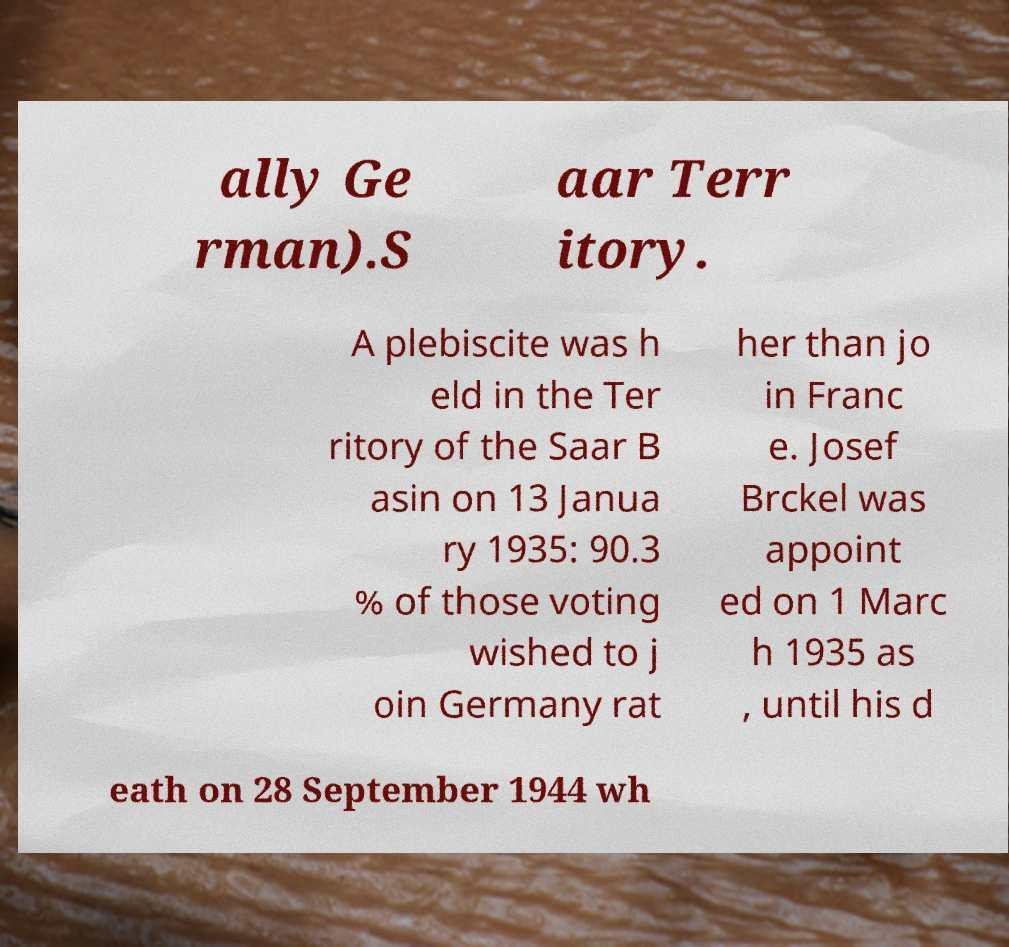Please identify and transcribe the text found in this image. ally Ge rman).S aar Terr itory. A plebiscite was h eld in the Ter ritory of the Saar B asin on 13 Janua ry 1935: 90.3 % of those voting wished to j oin Germany rat her than jo in Franc e. Josef Brckel was appoint ed on 1 Marc h 1935 as , until his d eath on 28 September 1944 wh 